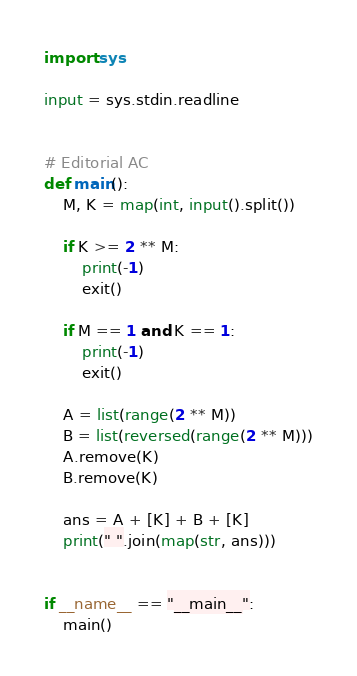Convert code to text. <code><loc_0><loc_0><loc_500><loc_500><_Python_>import sys

input = sys.stdin.readline


# Editorial AC
def main():
    M, K = map(int, input().split())

    if K >= 2 ** M:
        print(-1)
        exit()

    if M == 1 and K == 1:
        print(-1)
        exit()

    A = list(range(2 ** M))
    B = list(reversed(range(2 ** M)))
    A.remove(K)
    B.remove(K)

    ans = A + [K] + B + [K]
    print(" ".join(map(str, ans)))


if __name__ == "__main__":
    main()
</code> 